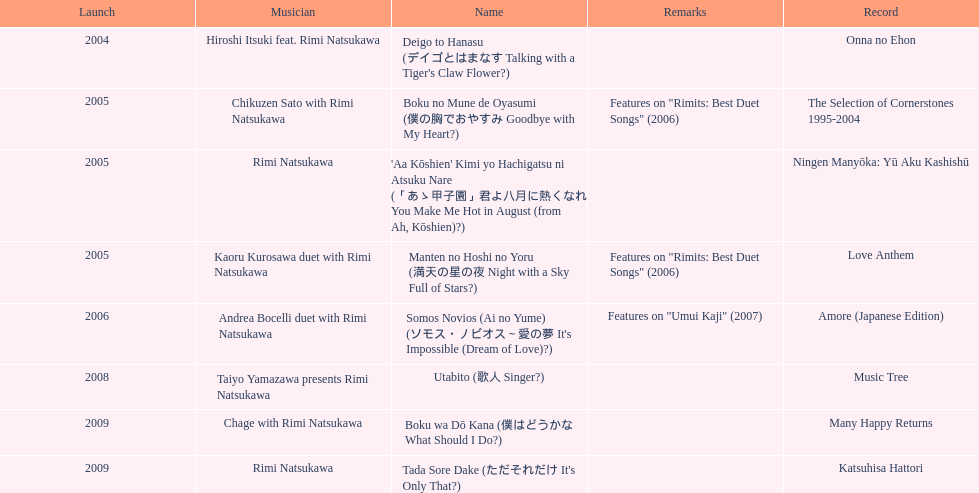Which title of the rimi natsukawa discography was released in the 2004? Deigo to Hanasu (デイゴとはまなす Talking with a Tiger's Claw Flower?). Which title has notes that features on/rimits. best duet songs\2006 Manten no Hoshi no Yoru (満天の星の夜 Night with a Sky Full of Stars?). Which title share the same notes as night with a sky full of stars? Boku no Mune de Oyasumi (僕の胸でおやすみ Goodbye with My Heart?). 